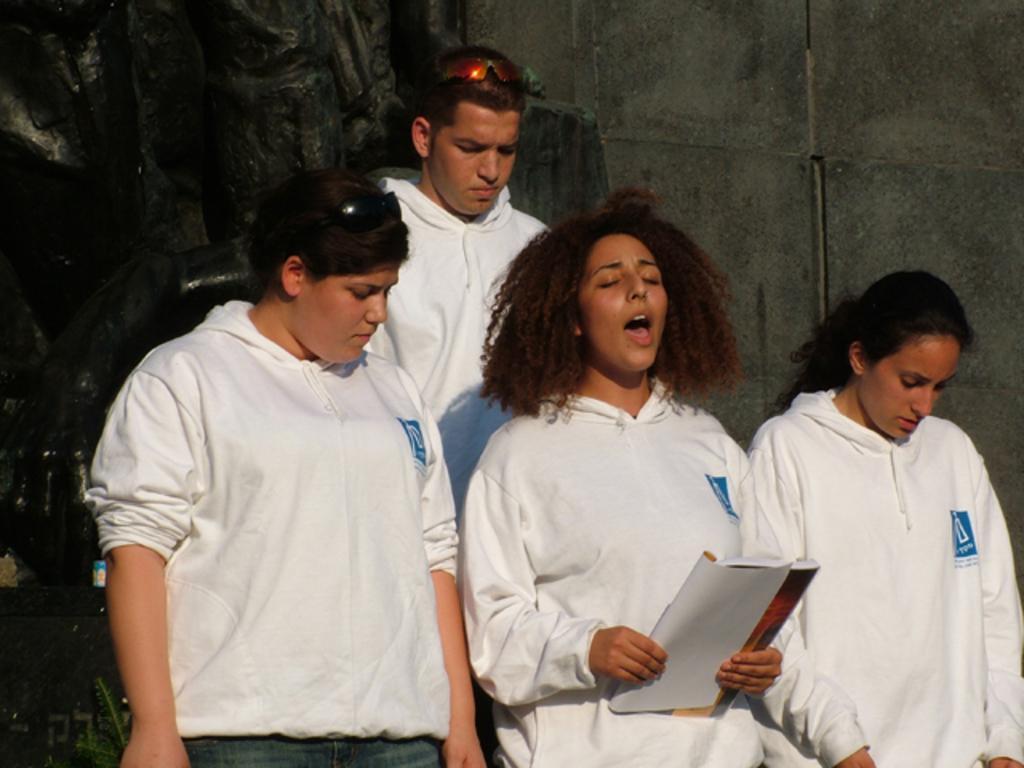Please provide a concise description of this image. In this image there are four people standing , a person holding a book, wall. 